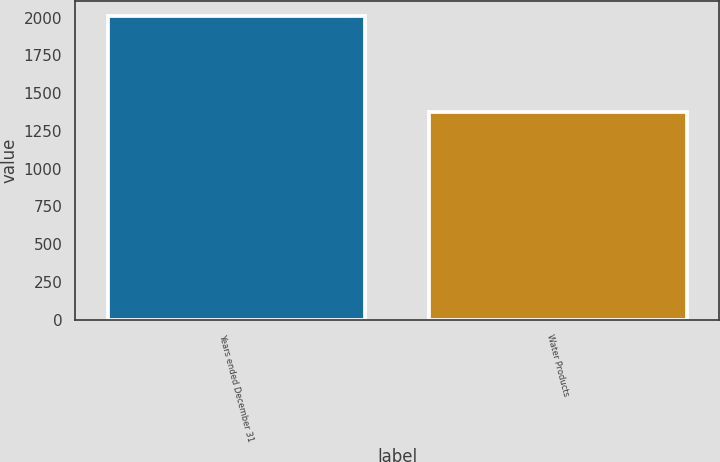Convert chart. <chart><loc_0><loc_0><loc_500><loc_500><bar_chart><fcel>Years ended December 31<fcel>Water Products<nl><fcel>2009<fcel>1375<nl></chart> 